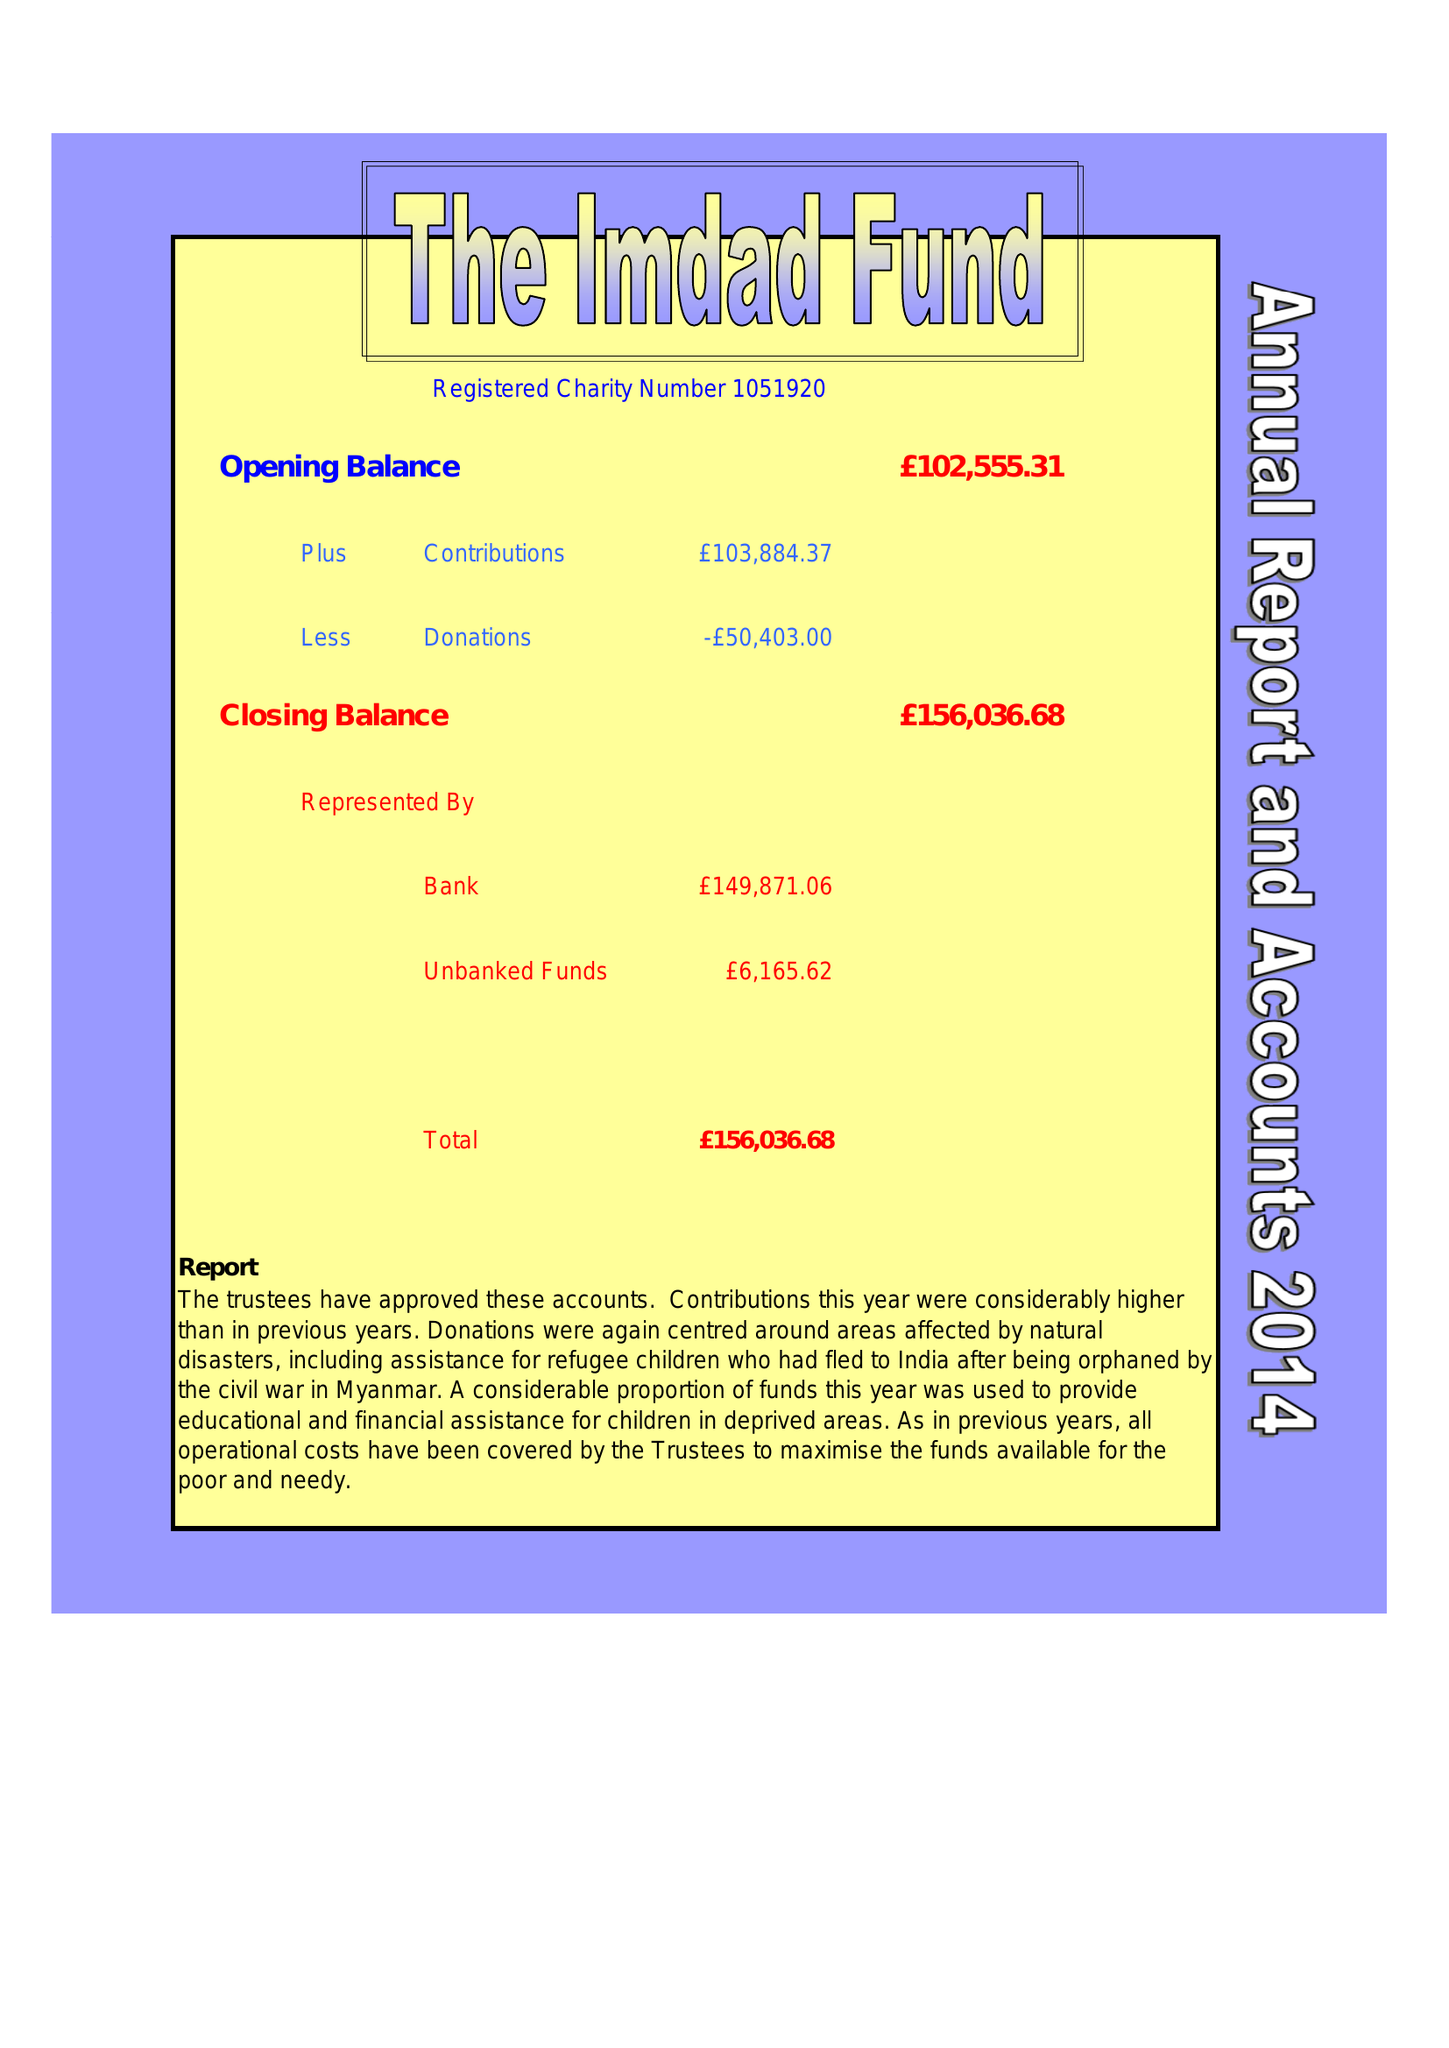What is the value for the address__post_town?
Answer the question using a single word or phrase. LONDON 